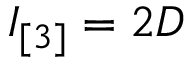<formula> <loc_0><loc_0><loc_500><loc_500>I _ { [ 3 ] } = 2 D</formula> 